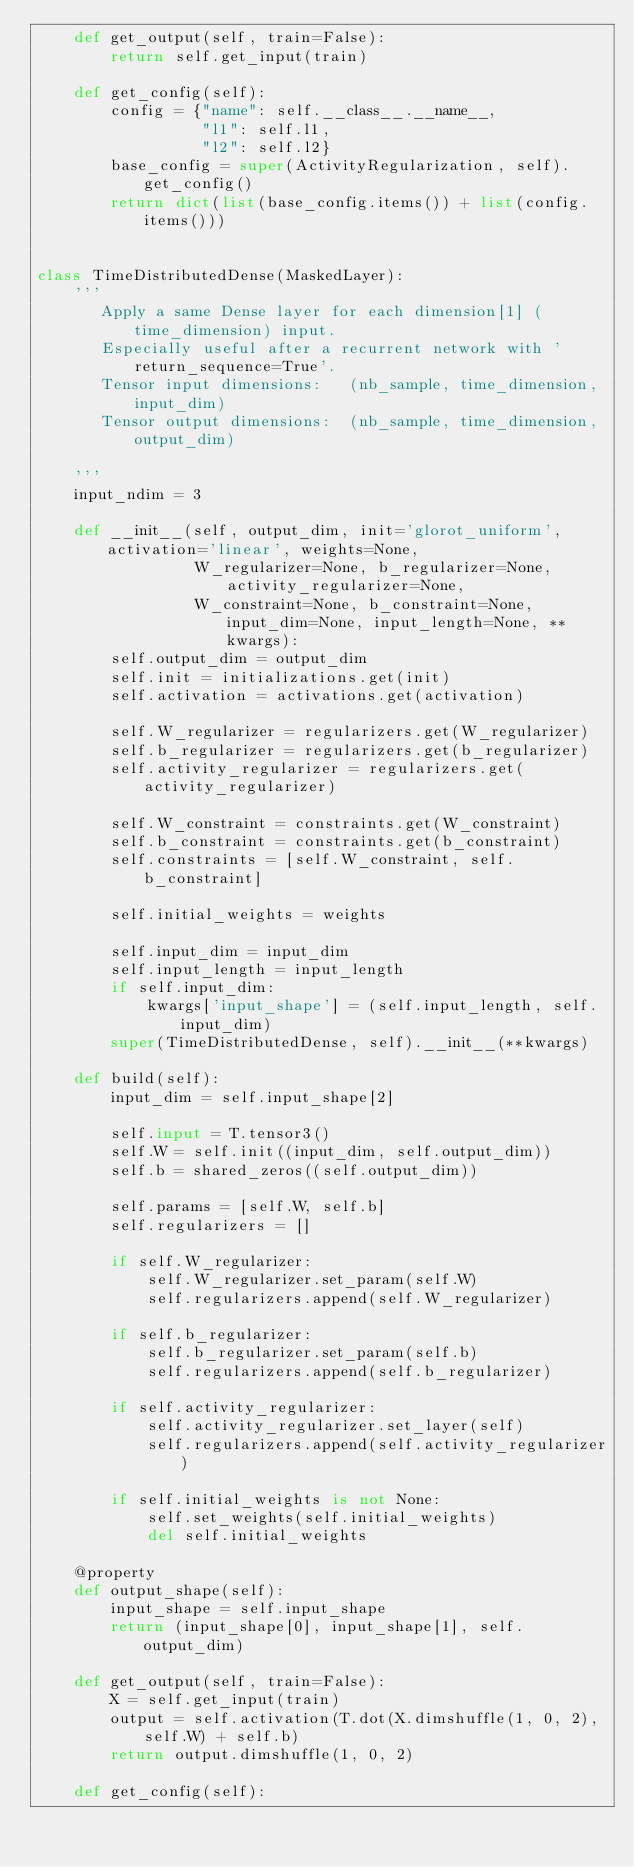<code> <loc_0><loc_0><loc_500><loc_500><_Python_>    def get_output(self, train=False):
        return self.get_input(train)

    def get_config(self):
        config = {"name": self.__class__.__name__,
                  "l1": self.l1,
                  "l2": self.l2}
        base_config = super(ActivityRegularization, self).get_config()
        return dict(list(base_config.items()) + list(config.items()))


class TimeDistributedDense(MaskedLayer):
    '''
       Apply a same Dense layer for each dimension[1] (time_dimension) input.
       Especially useful after a recurrent network with 'return_sequence=True'.
       Tensor input dimensions:   (nb_sample, time_dimension, input_dim)
       Tensor output dimensions:  (nb_sample, time_dimension, output_dim)

    '''
    input_ndim = 3

    def __init__(self, output_dim, init='glorot_uniform', activation='linear', weights=None,
                 W_regularizer=None, b_regularizer=None, activity_regularizer=None,
                 W_constraint=None, b_constraint=None, input_dim=None, input_length=None, **kwargs):
        self.output_dim = output_dim
        self.init = initializations.get(init)
        self.activation = activations.get(activation)

        self.W_regularizer = regularizers.get(W_regularizer)
        self.b_regularizer = regularizers.get(b_regularizer)
        self.activity_regularizer = regularizers.get(activity_regularizer)

        self.W_constraint = constraints.get(W_constraint)
        self.b_constraint = constraints.get(b_constraint)
        self.constraints = [self.W_constraint, self.b_constraint]

        self.initial_weights = weights

        self.input_dim = input_dim
        self.input_length = input_length
        if self.input_dim:
            kwargs['input_shape'] = (self.input_length, self.input_dim)
        super(TimeDistributedDense, self).__init__(**kwargs)

    def build(self):
        input_dim = self.input_shape[2]

        self.input = T.tensor3()
        self.W = self.init((input_dim, self.output_dim))
        self.b = shared_zeros((self.output_dim))

        self.params = [self.W, self.b]
        self.regularizers = []

        if self.W_regularizer:
            self.W_regularizer.set_param(self.W)
            self.regularizers.append(self.W_regularizer)

        if self.b_regularizer:
            self.b_regularizer.set_param(self.b)
            self.regularizers.append(self.b_regularizer)

        if self.activity_regularizer:
            self.activity_regularizer.set_layer(self)
            self.regularizers.append(self.activity_regularizer)

        if self.initial_weights is not None:
            self.set_weights(self.initial_weights)
            del self.initial_weights

    @property
    def output_shape(self):
        input_shape = self.input_shape
        return (input_shape[0], input_shape[1], self.output_dim)

    def get_output(self, train=False):
        X = self.get_input(train)
        output = self.activation(T.dot(X.dimshuffle(1, 0, 2), self.W) + self.b)
        return output.dimshuffle(1, 0, 2)

    def get_config(self):</code> 